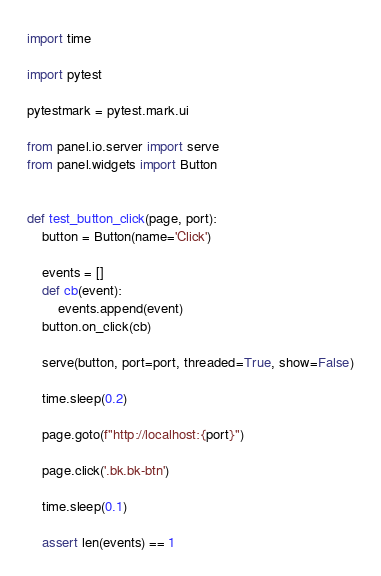<code> <loc_0><loc_0><loc_500><loc_500><_Python_>import time

import pytest

pytestmark = pytest.mark.ui

from panel.io.server import serve
from panel.widgets import Button


def test_button_click(page, port):
    button = Button(name='Click')

    events = []
    def cb(event):
        events.append(event)
    button.on_click(cb)

    serve(button, port=port, threaded=True, show=False)

    time.sleep(0.2)

    page.goto(f"http://localhost:{port}")

    page.click('.bk.bk-btn')

    time.sleep(0.1)

    assert len(events) == 1
</code> 